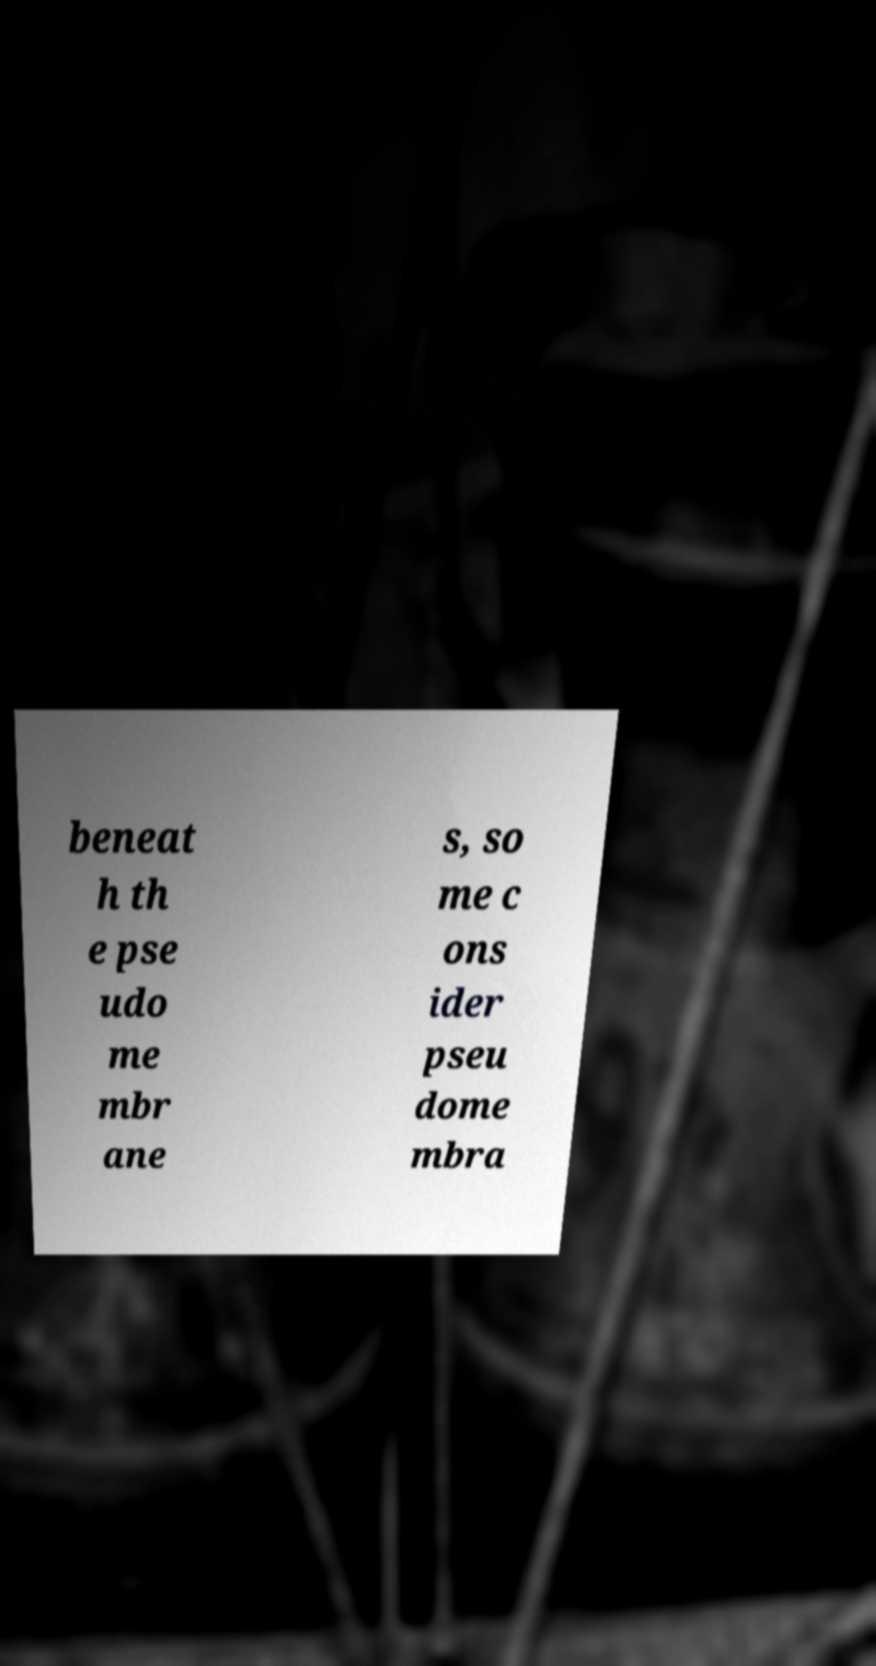There's text embedded in this image that I need extracted. Can you transcribe it verbatim? beneat h th e pse udo me mbr ane s, so me c ons ider pseu dome mbra 